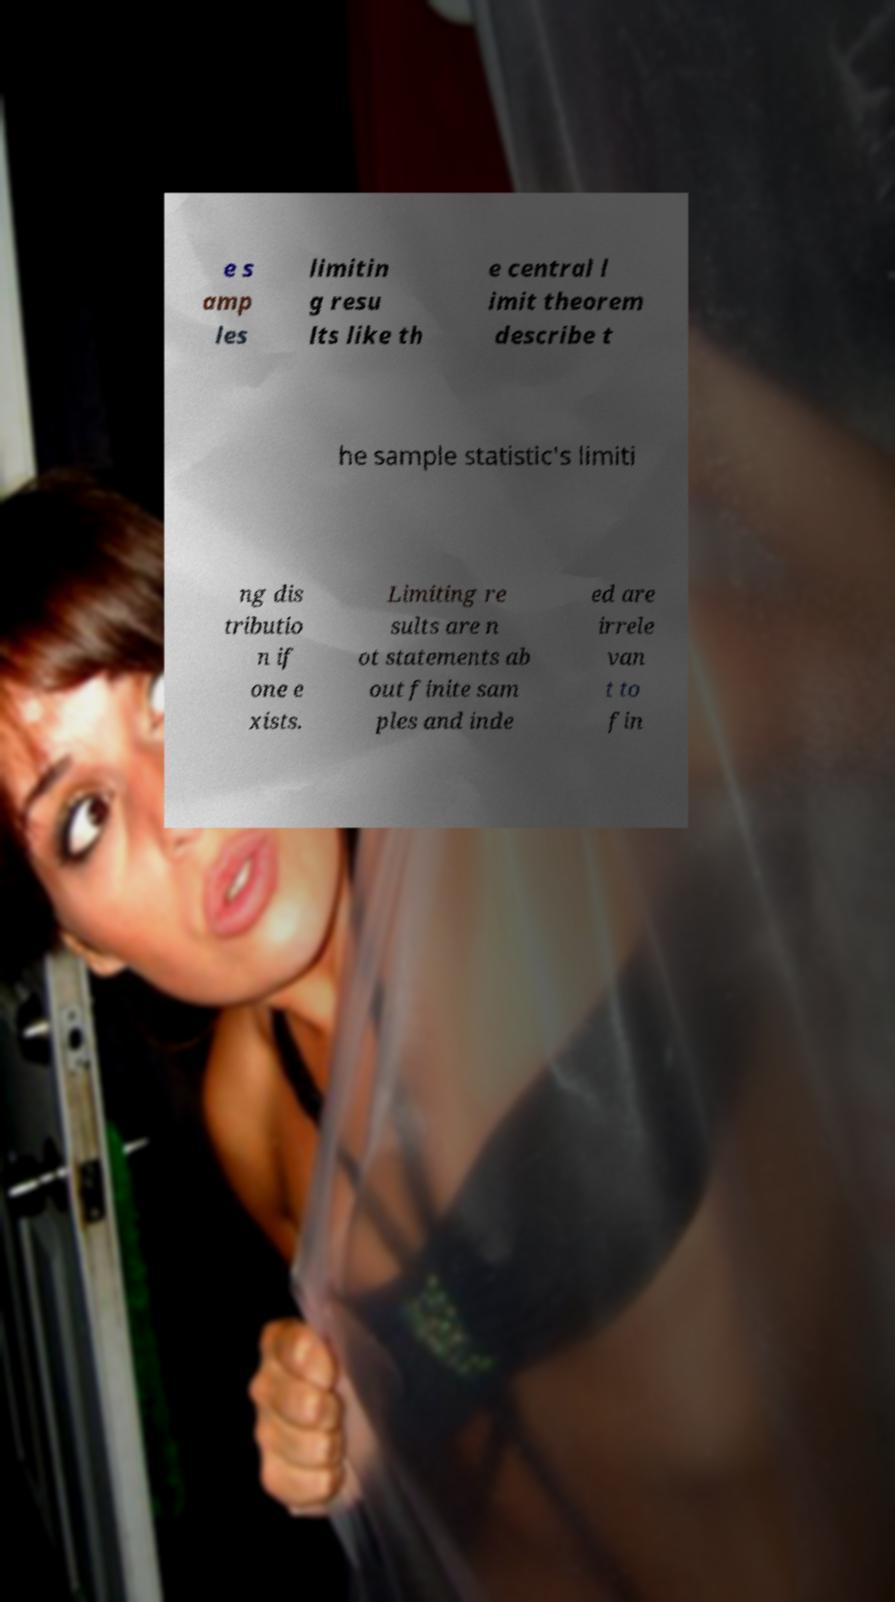Can you accurately transcribe the text from the provided image for me? e s amp les limitin g resu lts like th e central l imit theorem describe t he sample statistic's limiti ng dis tributio n if one e xists. Limiting re sults are n ot statements ab out finite sam ples and inde ed are irrele van t to fin 